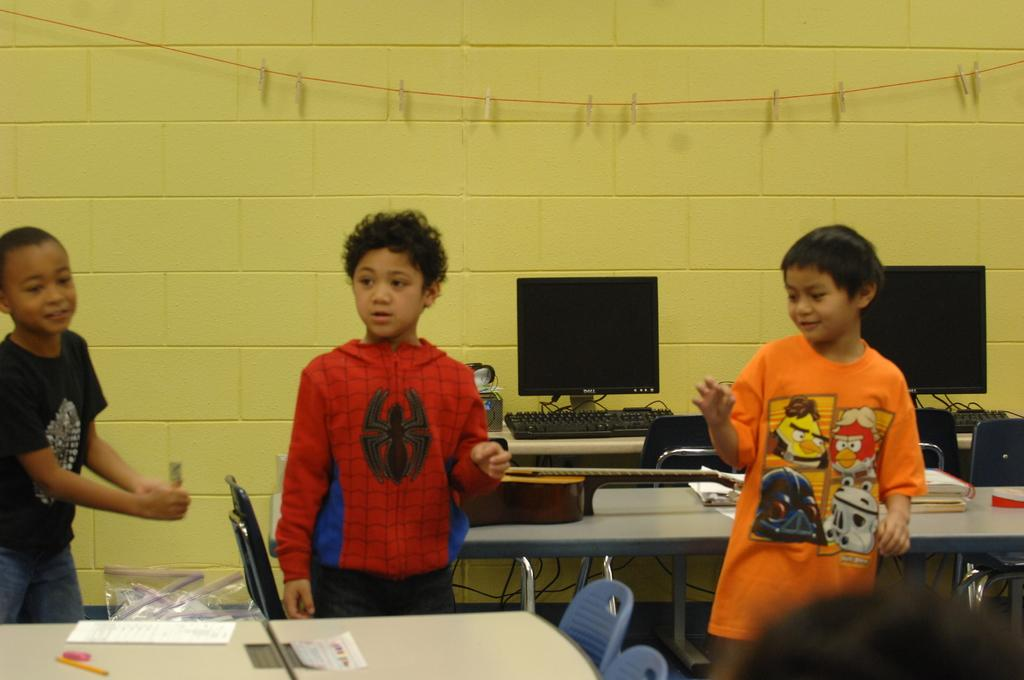Who is present in the image? There are kids in the image. What are the kids doing in the image? The kids are standing. What object can be seen on the table in the image? There is a monitor on the table. What might the kids be looking at or interacting with in the image? They might be looking at or interacting with the monitor on the table. What type of seed can be seen growing in a circle around the kids in the image? There is no seed or circle present in the image; it only features kids standing and a table with a monitor. 